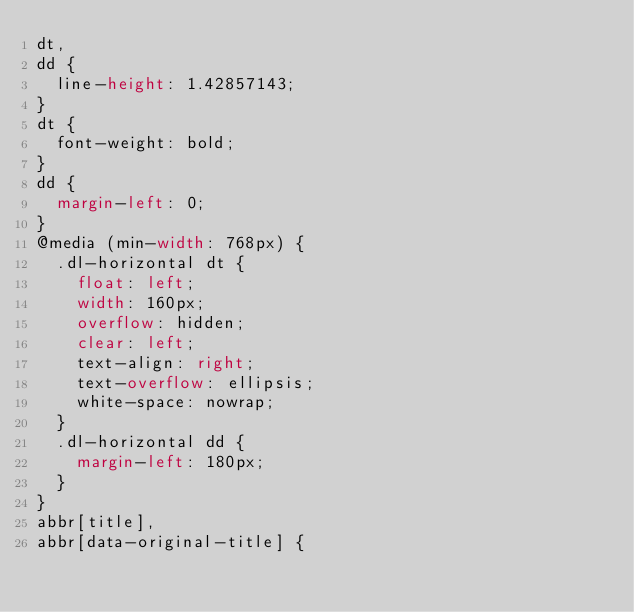<code> <loc_0><loc_0><loc_500><loc_500><_CSS_>dt,
dd {
  line-height: 1.42857143;
}
dt {
  font-weight: bold;
}
dd {
  margin-left: 0;
}
@media (min-width: 768px) {
  .dl-horizontal dt {
    float: left;
    width: 160px;
    overflow: hidden;
    clear: left;
    text-align: right;
    text-overflow: ellipsis;
    white-space: nowrap;
  }
  .dl-horizontal dd {
    margin-left: 180px;
  }
}
abbr[title],
abbr[data-original-title] {</code> 